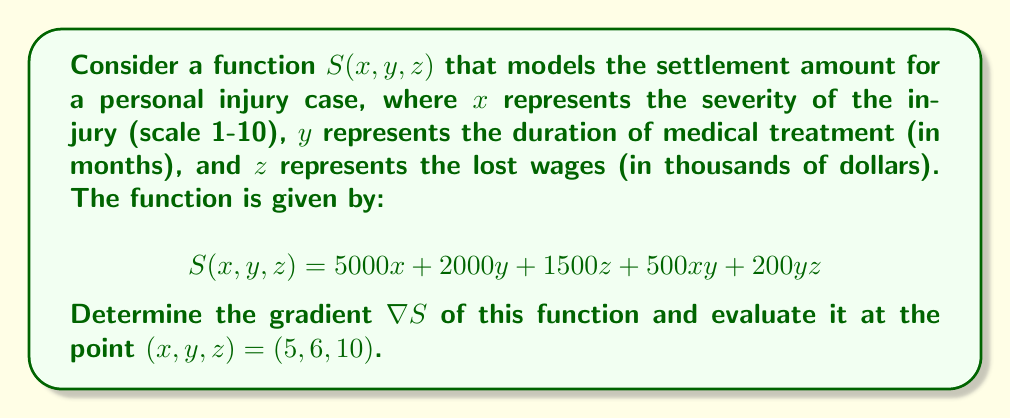Provide a solution to this math problem. To solve this problem, we need to follow these steps:

1) The gradient of a function $f(x, y, z)$ is defined as:

   $$\nabla f = \left(\frac{\partial f}{\partial x}, \frac{\partial f}{\partial y}, \frac{\partial f}{\partial z}\right)$$

2) For our function $S(x, y, z)$, we need to calculate each partial derivative:

   a) $\frac{\partial S}{\partial x} = 5000 + 500y$
   b) $\frac{\partial S}{\partial y} = 2000 + 500x + 200z$
   c) $\frac{\partial S}{\partial z} = 1500 + 200y$

3) Therefore, the gradient of $S$ is:

   $$\nabla S = (5000 + 500y, 2000 + 500x + 200z, 1500 + 200y)$$

4) To evaluate this at the point $(5, 6, 10)$, we substitute these values:

   $$\nabla S(5, 6, 10) = (5000 + 500(6), 2000 + 500(5) + 200(10), 1500 + 200(6))$$

5) Simplifying:

   $$\nabla S(5, 6, 10) = (8000, 6500, 2700)$$

This gradient vector indicates the direction of steepest increase in the settlement amount at the given point, and its magnitude represents the rate of this increase.
Answer: $$\nabla S = (5000 + 500y, 2000 + 500x + 200z, 1500 + 200y)$$
$$\nabla S(5, 6, 10) = (8000, 6500, 2700)$$ 